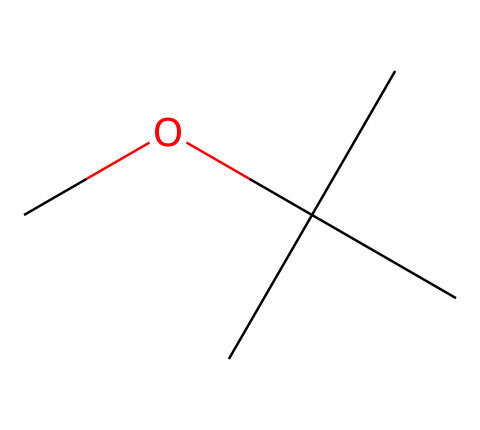What is the name of this chemical? The chemical represented by the SMILES is methyl tert-butyl ether, which indicates it is an ether since it contains an oxygen atom bonded to two alkyl groups.
Answer: methyl tert-butyl ether How many carbon atoms are in this structure? By analyzing the SMILES, there are four carbon atoms from the tert-butyl group (C(C)(C)C) and one from the methoxy group (CO), totaling five.
Answer: five What type of functional group is present in this compound? The presence of an oxygen atom bonded to carbon atoms classifies this compound as an ether, which is a unique type of functional group in organic chemistry.
Answer: ether What is the total number of hydrogen atoms in this structure? The tert-butyl group contributes nine hydrogen atoms (C(C)(C)C) and the methoxy group adds three (CO), resulting in a total of twelve hydrogen atoms.
Answer: twelve How does the branching of carbon atoms affect the boiling point of MTBE? The branched structure of MTBE leads to a lower boiling point compared to straight-chain isomers, as branching reduces surface area, leading to weaker van der Waals forces.
Answer: lower Is MTBE polar or nonpolar? The presence of the ether functional group and the overall structure suggests that MTBE exhibits a low level of polarity due to the electronegative oxygen atom and the bulky carbon groups.
Answer: nonpolar 